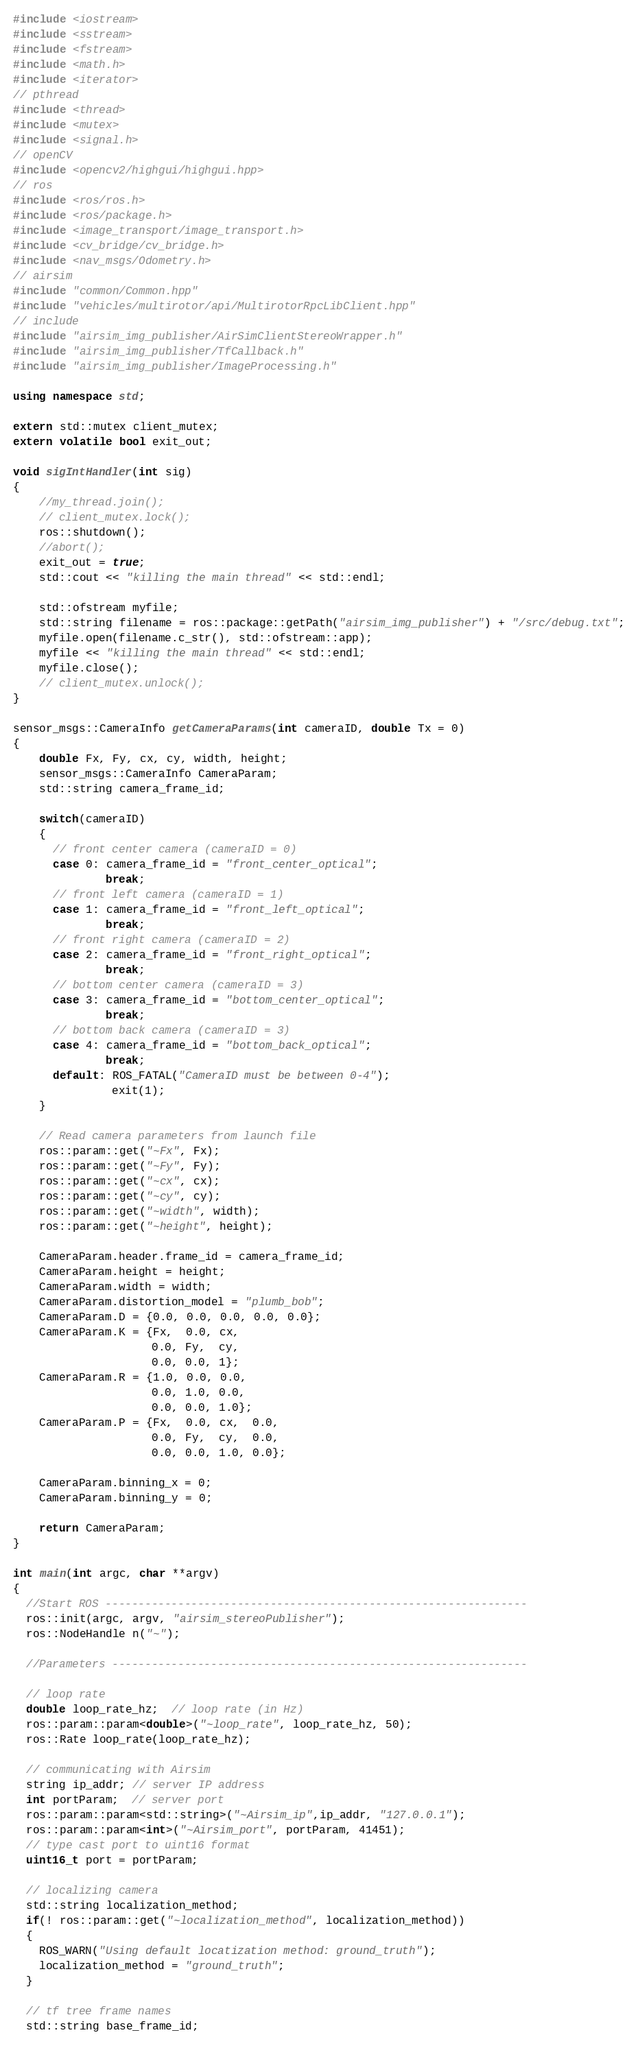Convert code to text. <code><loc_0><loc_0><loc_500><loc_500><_C++_>#include <iostream>
#include <sstream>
#include <fstream>
#include <math.h>
#include <iterator>
// pthread
#include <thread>
#include <mutex>
#include <signal.h>
// openCV
#include <opencv2/highgui/highgui.hpp>
// ros
#include <ros/ros.h>
#include <ros/package.h>
#include <image_transport/image_transport.h>
#include <cv_bridge/cv_bridge.h>
#include <nav_msgs/Odometry.h>
// airsim
#include "common/Common.hpp"
#include "vehicles/multirotor/api/MultirotorRpcLibClient.hpp"
// include
#include "airsim_img_publisher/AirSimClientStereoWrapper.h"
#include "airsim_img_publisher/TfCallback.h"
#include "airsim_img_publisher/ImageProcessing.h"

using namespace std;

extern std::mutex client_mutex;
extern volatile bool exit_out;

void sigIntHandler(int sig)
{
    //my_thread.join();
    // client_mutex.lock();
    ros::shutdown();
    //abort();
    exit_out = true;
    std::cout << "killing the main thread" << std::endl;

    std::ofstream myfile;
    std::string filename = ros::package::getPath("airsim_img_publisher") + "/src/debug.txt";
    myfile.open(filename.c_str(), std::ofstream::app);
    myfile << "killing the main thread" << std::endl;
    myfile.close();
    // client_mutex.unlock();
}

sensor_msgs::CameraInfo getCameraParams(int cameraID, double Tx = 0)
{
    double Fx, Fy, cx, cy, width, height;
    sensor_msgs::CameraInfo CameraParam;
    std::string camera_frame_id;

    switch(cameraID)
    {
      // front center camera (cameraID = 0)
      case 0: camera_frame_id = "front_center_optical";
              break;
      // front left camera (cameraID = 1)
      case 1: camera_frame_id = "front_left_optical";
              break;
      // front right camera (cameraID = 2)
      case 2: camera_frame_id = "front_right_optical";
              break;
      // bottom center camera (cameraID = 3)
      case 3: camera_frame_id = "bottom_center_optical";
              break;
      // bottom back camera (cameraID = 3)
      case 4: camera_frame_id = "bottom_back_optical";
              break;
      default: ROS_FATAL("CameraID must be between 0-4");
               exit(1);
    }

    // Read camera parameters from launch file
    ros::param::get("~Fx", Fx);
    ros::param::get("~Fy", Fy);
    ros::param::get("~cx", cx);
    ros::param::get("~cy", cy);
    ros::param::get("~width", width);
    ros::param::get("~height", height);

    CameraParam.header.frame_id = camera_frame_id;
    CameraParam.height = height;
    CameraParam.width = width;
    CameraParam.distortion_model = "plumb_bob";
    CameraParam.D = {0.0, 0.0, 0.0, 0.0, 0.0};
    CameraParam.K = {Fx,  0.0, cx,
                     0.0, Fy,  cy,
                     0.0, 0.0, 1};
    CameraParam.R = {1.0, 0.0, 0.0,
                     0.0, 1.0, 0.0,
                     0.0, 0.0, 1.0};
    CameraParam.P = {Fx,  0.0, cx,  0.0,
                     0.0, Fy,  cy,  0.0,
                     0.0, 0.0, 1.0, 0.0};

    CameraParam.binning_x = 0;
    CameraParam.binning_y = 0;

    return CameraParam;
}

int main(int argc, char **argv)
{
  //Start ROS ----------------------------------------------------------------
  ros::init(argc, argv, "airsim_stereoPublisher");
  ros::NodeHandle n("~");

  //Parameters ---------------------------------------------------------------

  // loop rate
  double loop_rate_hz;  // loop rate (in Hz)
  ros::param::param<double>("~loop_rate", loop_rate_hz, 50);
  ros::Rate loop_rate(loop_rate_hz);

  // communicating with Airsim
  string ip_addr; // server IP address
  int portParam;  // server port
  ros::param::param<std::string>("~Airsim_ip",ip_addr, "127.0.0.1");
  ros::param::param<int>("~Airsim_port", portParam, 41451);
  // type cast port to uint16 format
  uint16_t port = portParam;

  // localizing camera
  std::string localization_method;
  if(! ros::param::get("~localization_method", localization_method))
  {
    ROS_WARN("Using default locatization method: ground_truth");
    localization_method = "ground_truth";
  }

  // tf tree frame names
  std::string base_frame_id;</code> 